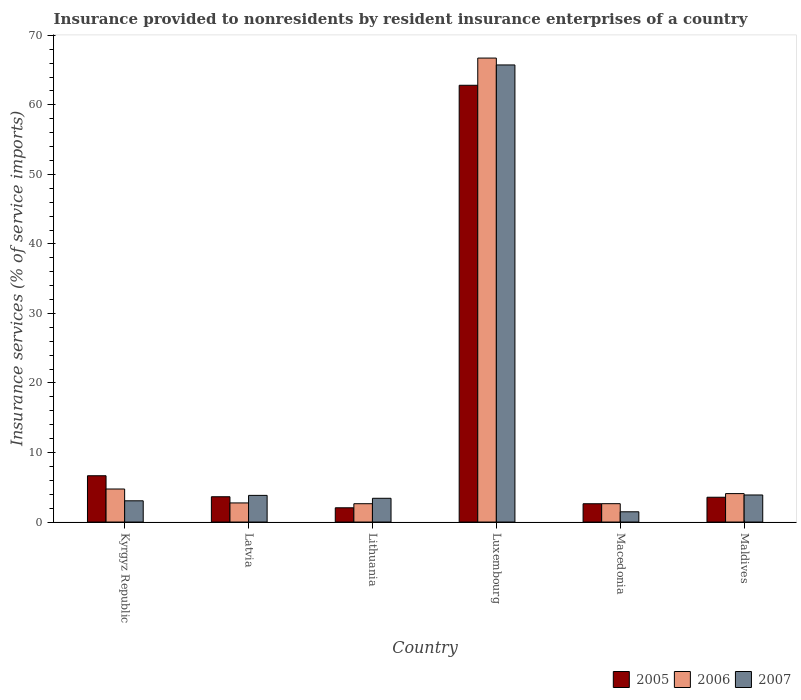How many different coloured bars are there?
Offer a very short reply. 3. Are the number of bars per tick equal to the number of legend labels?
Ensure brevity in your answer.  Yes. How many bars are there on the 3rd tick from the left?
Your answer should be compact. 3. How many bars are there on the 3rd tick from the right?
Provide a short and direct response. 3. What is the label of the 6th group of bars from the left?
Make the answer very short. Maldives. In how many cases, is the number of bars for a given country not equal to the number of legend labels?
Provide a succinct answer. 0. What is the insurance provided to nonresidents in 2007 in Maldives?
Offer a very short reply. 3.89. Across all countries, what is the maximum insurance provided to nonresidents in 2005?
Provide a succinct answer. 62.82. Across all countries, what is the minimum insurance provided to nonresidents in 2006?
Keep it short and to the point. 2.64. In which country was the insurance provided to nonresidents in 2006 maximum?
Provide a short and direct response. Luxembourg. In which country was the insurance provided to nonresidents in 2007 minimum?
Make the answer very short. Macedonia. What is the total insurance provided to nonresidents in 2007 in the graph?
Your response must be concise. 81.41. What is the difference between the insurance provided to nonresidents in 2006 in Latvia and that in Maldives?
Provide a short and direct response. -1.34. What is the difference between the insurance provided to nonresidents in 2005 in Lithuania and the insurance provided to nonresidents in 2007 in Kyrgyz Republic?
Make the answer very short. -1. What is the average insurance provided to nonresidents in 2007 per country?
Ensure brevity in your answer.  13.57. What is the difference between the insurance provided to nonresidents of/in 2005 and insurance provided to nonresidents of/in 2007 in Lithuania?
Make the answer very short. -1.37. In how many countries, is the insurance provided to nonresidents in 2005 greater than 64 %?
Provide a succinct answer. 0. What is the ratio of the insurance provided to nonresidents in 2007 in Lithuania to that in Macedonia?
Make the answer very short. 2.32. Is the insurance provided to nonresidents in 2007 in Kyrgyz Republic less than that in Macedonia?
Provide a short and direct response. No. What is the difference between the highest and the second highest insurance provided to nonresidents in 2005?
Your response must be concise. -59.18. What is the difference between the highest and the lowest insurance provided to nonresidents in 2005?
Offer a very short reply. 60.77. In how many countries, is the insurance provided to nonresidents in 2005 greater than the average insurance provided to nonresidents in 2005 taken over all countries?
Make the answer very short. 1. Is the sum of the insurance provided to nonresidents in 2006 in Latvia and Maldives greater than the maximum insurance provided to nonresidents in 2007 across all countries?
Ensure brevity in your answer.  No. What does the 1st bar from the left in Luxembourg represents?
Your answer should be very brief. 2005. How many bars are there?
Give a very brief answer. 18. Does the graph contain any zero values?
Offer a very short reply. No. How many legend labels are there?
Your response must be concise. 3. How are the legend labels stacked?
Provide a short and direct response. Horizontal. What is the title of the graph?
Give a very brief answer. Insurance provided to nonresidents by resident insurance enterprises of a country. What is the label or title of the X-axis?
Keep it short and to the point. Country. What is the label or title of the Y-axis?
Give a very brief answer. Insurance services (% of service imports). What is the Insurance services (% of service imports) of 2005 in Kyrgyz Republic?
Provide a succinct answer. 6.66. What is the Insurance services (% of service imports) in 2006 in Kyrgyz Republic?
Give a very brief answer. 4.75. What is the Insurance services (% of service imports) in 2007 in Kyrgyz Republic?
Ensure brevity in your answer.  3.05. What is the Insurance services (% of service imports) in 2005 in Latvia?
Make the answer very short. 3.64. What is the Insurance services (% of service imports) in 2006 in Latvia?
Your response must be concise. 2.75. What is the Insurance services (% of service imports) of 2007 in Latvia?
Provide a short and direct response. 3.83. What is the Insurance services (% of service imports) of 2005 in Lithuania?
Your answer should be very brief. 2.05. What is the Insurance services (% of service imports) in 2006 in Lithuania?
Provide a succinct answer. 2.64. What is the Insurance services (% of service imports) in 2007 in Lithuania?
Your answer should be compact. 3.42. What is the Insurance services (% of service imports) of 2005 in Luxembourg?
Give a very brief answer. 62.82. What is the Insurance services (% of service imports) in 2006 in Luxembourg?
Your answer should be very brief. 66.73. What is the Insurance services (% of service imports) of 2007 in Luxembourg?
Provide a succinct answer. 65.74. What is the Insurance services (% of service imports) of 2005 in Macedonia?
Give a very brief answer. 2.63. What is the Insurance services (% of service imports) in 2006 in Macedonia?
Provide a short and direct response. 2.64. What is the Insurance services (% of service imports) in 2007 in Macedonia?
Make the answer very short. 1.47. What is the Insurance services (% of service imports) in 2005 in Maldives?
Give a very brief answer. 3.57. What is the Insurance services (% of service imports) in 2006 in Maldives?
Give a very brief answer. 4.09. What is the Insurance services (% of service imports) of 2007 in Maldives?
Provide a succinct answer. 3.89. Across all countries, what is the maximum Insurance services (% of service imports) of 2005?
Your response must be concise. 62.82. Across all countries, what is the maximum Insurance services (% of service imports) of 2006?
Make the answer very short. 66.73. Across all countries, what is the maximum Insurance services (% of service imports) of 2007?
Make the answer very short. 65.74. Across all countries, what is the minimum Insurance services (% of service imports) in 2005?
Offer a terse response. 2.05. Across all countries, what is the minimum Insurance services (% of service imports) of 2006?
Offer a terse response. 2.64. Across all countries, what is the minimum Insurance services (% of service imports) in 2007?
Your response must be concise. 1.47. What is the total Insurance services (% of service imports) in 2005 in the graph?
Offer a terse response. 81.36. What is the total Insurance services (% of service imports) in 2006 in the graph?
Ensure brevity in your answer.  83.59. What is the total Insurance services (% of service imports) of 2007 in the graph?
Give a very brief answer. 81.41. What is the difference between the Insurance services (% of service imports) in 2005 in Kyrgyz Republic and that in Latvia?
Keep it short and to the point. 3.02. What is the difference between the Insurance services (% of service imports) of 2006 in Kyrgyz Republic and that in Latvia?
Your answer should be very brief. 2. What is the difference between the Insurance services (% of service imports) in 2007 in Kyrgyz Republic and that in Latvia?
Ensure brevity in your answer.  -0.78. What is the difference between the Insurance services (% of service imports) of 2005 in Kyrgyz Republic and that in Lithuania?
Give a very brief answer. 4.61. What is the difference between the Insurance services (% of service imports) in 2006 in Kyrgyz Republic and that in Lithuania?
Provide a succinct answer. 2.11. What is the difference between the Insurance services (% of service imports) in 2007 in Kyrgyz Republic and that in Lithuania?
Offer a terse response. -0.36. What is the difference between the Insurance services (% of service imports) in 2005 in Kyrgyz Republic and that in Luxembourg?
Your response must be concise. -56.16. What is the difference between the Insurance services (% of service imports) in 2006 in Kyrgyz Republic and that in Luxembourg?
Offer a terse response. -61.98. What is the difference between the Insurance services (% of service imports) in 2007 in Kyrgyz Republic and that in Luxembourg?
Your answer should be compact. -62.69. What is the difference between the Insurance services (% of service imports) in 2005 in Kyrgyz Republic and that in Macedonia?
Provide a succinct answer. 4.03. What is the difference between the Insurance services (% of service imports) in 2006 in Kyrgyz Republic and that in Macedonia?
Offer a very short reply. 2.11. What is the difference between the Insurance services (% of service imports) in 2007 in Kyrgyz Republic and that in Macedonia?
Offer a terse response. 1.58. What is the difference between the Insurance services (% of service imports) of 2005 in Kyrgyz Republic and that in Maldives?
Offer a terse response. 3.09. What is the difference between the Insurance services (% of service imports) in 2006 in Kyrgyz Republic and that in Maldives?
Offer a terse response. 0.66. What is the difference between the Insurance services (% of service imports) in 2007 in Kyrgyz Republic and that in Maldives?
Provide a succinct answer. -0.84. What is the difference between the Insurance services (% of service imports) of 2005 in Latvia and that in Lithuania?
Your answer should be very brief. 1.59. What is the difference between the Insurance services (% of service imports) of 2006 in Latvia and that in Lithuania?
Ensure brevity in your answer.  0.11. What is the difference between the Insurance services (% of service imports) of 2007 in Latvia and that in Lithuania?
Provide a succinct answer. 0.42. What is the difference between the Insurance services (% of service imports) in 2005 in Latvia and that in Luxembourg?
Ensure brevity in your answer.  -59.18. What is the difference between the Insurance services (% of service imports) in 2006 in Latvia and that in Luxembourg?
Provide a short and direct response. -63.98. What is the difference between the Insurance services (% of service imports) of 2007 in Latvia and that in Luxembourg?
Offer a terse response. -61.91. What is the difference between the Insurance services (% of service imports) in 2005 in Latvia and that in Macedonia?
Keep it short and to the point. 1.01. What is the difference between the Insurance services (% of service imports) in 2006 in Latvia and that in Macedonia?
Provide a short and direct response. 0.11. What is the difference between the Insurance services (% of service imports) of 2007 in Latvia and that in Macedonia?
Offer a very short reply. 2.36. What is the difference between the Insurance services (% of service imports) in 2005 in Latvia and that in Maldives?
Keep it short and to the point. 0.07. What is the difference between the Insurance services (% of service imports) in 2006 in Latvia and that in Maldives?
Provide a short and direct response. -1.34. What is the difference between the Insurance services (% of service imports) of 2007 in Latvia and that in Maldives?
Offer a terse response. -0.06. What is the difference between the Insurance services (% of service imports) in 2005 in Lithuania and that in Luxembourg?
Offer a terse response. -60.77. What is the difference between the Insurance services (% of service imports) of 2006 in Lithuania and that in Luxembourg?
Ensure brevity in your answer.  -64.09. What is the difference between the Insurance services (% of service imports) in 2007 in Lithuania and that in Luxembourg?
Provide a succinct answer. -62.33. What is the difference between the Insurance services (% of service imports) of 2005 in Lithuania and that in Macedonia?
Your answer should be compact. -0.58. What is the difference between the Insurance services (% of service imports) of 2006 in Lithuania and that in Macedonia?
Give a very brief answer. -0. What is the difference between the Insurance services (% of service imports) of 2007 in Lithuania and that in Macedonia?
Your answer should be compact. 1.94. What is the difference between the Insurance services (% of service imports) of 2005 in Lithuania and that in Maldives?
Your answer should be very brief. -1.52. What is the difference between the Insurance services (% of service imports) of 2006 in Lithuania and that in Maldives?
Keep it short and to the point. -1.45. What is the difference between the Insurance services (% of service imports) in 2007 in Lithuania and that in Maldives?
Your response must be concise. -0.48. What is the difference between the Insurance services (% of service imports) of 2005 in Luxembourg and that in Macedonia?
Give a very brief answer. 60.19. What is the difference between the Insurance services (% of service imports) in 2006 in Luxembourg and that in Macedonia?
Your answer should be very brief. 64.09. What is the difference between the Insurance services (% of service imports) in 2007 in Luxembourg and that in Macedonia?
Offer a very short reply. 64.27. What is the difference between the Insurance services (% of service imports) of 2005 in Luxembourg and that in Maldives?
Offer a terse response. 59.25. What is the difference between the Insurance services (% of service imports) of 2006 in Luxembourg and that in Maldives?
Provide a short and direct response. 62.64. What is the difference between the Insurance services (% of service imports) in 2007 in Luxembourg and that in Maldives?
Your answer should be compact. 61.85. What is the difference between the Insurance services (% of service imports) in 2005 in Macedonia and that in Maldives?
Ensure brevity in your answer.  -0.93. What is the difference between the Insurance services (% of service imports) of 2006 in Macedonia and that in Maldives?
Give a very brief answer. -1.45. What is the difference between the Insurance services (% of service imports) of 2007 in Macedonia and that in Maldives?
Offer a terse response. -2.42. What is the difference between the Insurance services (% of service imports) of 2005 in Kyrgyz Republic and the Insurance services (% of service imports) of 2006 in Latvia?
Your response must be concise. 3.91. What is the difference between the Insurance services (% of service imports) in 2005 in Kyrgyz Republic and the Insurance services (% of service imports) in 2007 in Latvia?
Ensure brevity in your answer.  2.83. What is the difference between the Insurance services (% of service imports) in 2006 in Kyrgyz Republic and the Insurance services (% of service imports) in 2007 in Latvia?
Provide a short and direct response. 0.92. What is the difference between the Insurance services (% of service imports) in 2005 in Kyrgyz Republic and the Insurance services (% of service imports) in 2006 in Lithuania?
Your answer should be very brief. 4.02. What is the difference between the Insurance services (% of service imports) of 2005 in Kyrgyz Republic and the Insurance services (% of service imports) of 2007 in Lithuania?
Your answer should be very brief. 3.24. What is the difference between the Insurance services (% of service imports) in 2006 in Kyrgyz Republic and the Insurance services (% of service imports) in 2007 in Lithuania?
Provide a succinct answer. 1.34. What is the difference between the Insurance services (% of service imports) of 2005 in Kyrgyz Republic and the Insurance services (% of service imports) of 2006 in Luxembourg?
Your response must be concise. -60.07. What is the difference between the Insurance services (% of service imports) of 2005 in Kyrgyz Republic and the Insurance services (% of service imports) of 2007 in Luxembourg?
Give a very brief answer. -59.08. What is the difference between the Insurance services (% of service imports) of 2006 in Kyrgyz Republic and the Insurance services (% of service imports) of 2007 in Luxembourg?
Provide a short and direct response. -60.99. What is the difference between the Insurance services (% of service imports) in 2005 in Kyrgyz Republic and the Insurance services (% of service imports) in 2006 in Macedonia?
Provide a short and direct response. 4.02. What is the difference between the Insurance services (% of service imports) in 2005 in Kyrgyz Republic and the Insurance services (% of service imports) in 2007 in Macedonia?
Make the answer very short. 5.19. What is the difference between the Insurance services (% of service imports) of 2006 in Kyrgyz Republic and the Insurance services (% of service imports) of 2007 in Macedonia?
Offer a very short reply. 3.28. What is the difference between the Insurance services (% of service imports) of 2005 in Kyrgyz Republic and the Insurance services (% of service imports) of 2006 in Maldives?
Give a very brief answer. 2.57. What is the difference between the Insurance services (% of service imports) in 2005 in Kyrgyz Republic and the Insurance services (% of service imports) in 2007 in Maldives?
Ensure brevity in your answer.  2.77. What is the difference between the Insurance services (% of service imports) in 2006 in Kyrgyz Republic and the Insurance services (% of service imports) in 2007 in Maldives?
Offer a very short reply. 0.86. What is the difference between the Insurance services (% of service imports) of 2005 in Latvia and the Insurance services (% of service imports) of 2006 in Lithuania?
Provide a succinct answer. 1. What is the difference between the Insurance services (% of service imports) in 2005 in Latvia and the Insurance services (% of service imports) in 2007 in Lithuania?
Make the answer very short. 0.22. What is the difference between the Insurance services (% of service imports) in 2005 in Latvia and the Insurance services (% of service imports) in 2006 in Luxembourg?
Offer a terse response. -63.09. What is the difference between the Insurance services (% of service imports) of 2005 in Latvia and the Insurance services (% of service imports) of 2007 in Luxembourg?
Offer a very short reply. -62.1. What is the difference between the Insurance services (% of service imports) of 2006 in Latvia and the Insurance services (% of service imports) of 2007 in Luxembourg?
Your answer should be very brief. -62.99. What is the difference between the Insurance services (% of service imports) in 2005 in Latvia and the Insurance services (% of service imports) in 2007 in Macedonia?
Offer a terse response. 2.16. What is the difference between the Insurance services (% of service imports) in 2006 in Latvia and the Insurance services (% of service imports) in 2007 in Macedonia?
Provide a succinct answer. 1.28. What is the difference between the Insurance services (% of service imports) of 2005 in Latvia and the Insurance services (% of service imports) of 2006 in Maldives?
Make the answer very short. -0.45. What is the difference between the Insurance services (% of service imports) in 2005 in Latvia and the Insurance services (% of service imports) in 2007 in Maldives?
Give a very brief answer. -0.25. What is the difference between the Insurance services (% of service imports) of 2006 in Latvia and the Insurance services (% of service imports) of 2007 in Maldives?
Your answer should be very brief. -1.14. What is the difference between the Insurance services (% of service imports) in 2005 in Lithuania and the Insurance services (% of service imports) in 2006 in Luxembourg?
Your answer should be very brief. -64.68. What is the difference between the Insurance services (% of service imports) in 2005 in Lithuania and the Insurance services (% of service imports) in 2007 in Luxembourg?
Your response must be concise. -63.69. What is the difference between the Insurance services (% of service imports) of 2006 in Lithuania and the Insurance services (% of service imports) of 2007 in Luxembourg?
Make the answer very short. -63.1. What is the difference between the Insurance services (% of service imports) of 2005 in Lithuania and the Insurance services (% of service imports) of 2006 in Macedonia?
Your answer should be very brief. -0.59. What is the difference between the Insurance services (% of service imports) in 2005 in Lithuania and the Insurance services (% of service imports) in 2007 in Macedonia?
Offer a very short reply. 0.58. What is the difference between the Insurance services (% of service imports) in 2006 in Lithuania and the Insurance services (% of service imports) in 2007 in Macedonia?
Keep it short and to the point. 1.16. What is the difference between the Insurance services (% of service imports) of 2005 in Lithuania and the Insurance services (% of service imports) of 2006 in Maldives?
Provide a short and direct response. -2.04. What is the difference between the Insurance services (% of service imports) of 2005 in Lithuania and the Insurance services (% of service imports) of 2007 in Maldives?
Your response must be concise. -1.84. What is the difference between the Insurance services (% of service imports) of 2006 in Lithuania and the Insurance services (% of service imports) of 2007 in Maldives?
Your answer should be compact. -1.25. What is the difference between the Insurance services (% of service imports) in 2005 in Luxembourg and the Insurance services (% of service imports) in 2006 in Macedonia?
Keep it short and to the point. 60.18. What is the difference between the Insurance services (% of service imports) of 2005 in Luxembourg and the Insurance services (% of service imports) of 2007 in Macedonia?
Your response must be concise. 61.35. What is the difference between the Insurance services (% of service imports) in 2006 in Luxembourg and the Insurance services (% of service imports) in 2007 in Macedonia?
Your answer should be compact. 65.26. What is the difference between the Insurance services (% of service imports) in 2005 in Luxembourg and the Insurance services (% of service imports) in 2006 in Maldives?
Your answer should be very brief. 58.73. What is the difference between the Insurance services (% of service imports) of 2005 in Luxembourg and the Insurance services (% of service imports) of 2007 in Maldives?
Your answer should be compact. 58.93. What is the difference between the Insurance services (% of service imports) of 2006 in Luxembourg and the Insurance services (% of service imports) of 2007 in Maldives?
Ensure brevity in your answer.  62.84. What is the difference between the Insurance services (% of service imports) in 2005 in Macedonia and the Insurance services (% of service imports) in 2006 in Maldives?
Your answer should be compact. -1.46. What is the difference between the Insurance services (% of service imports) in 2005 in Macedonia and the Insurance services (% of service imports) in 2007 in Maldives?
Your response must be concise. -1.26. What is the difference between the Insurance services (% of service imports) of 2006 in Macedonia and the Insurance services (% of service imports) of 2007 in Maldives?
Your response must be concise. -1.25. What is the average Insurance services (% of service imports) of 2005 per country?
Your response must be concise. 13.56. What is the average Insurance services (% of service imports) in 2006 per country?
Provide a succinct answer. 13.93. What is the average Insurance services (% of service imports) in 2007 per country?
Your response must be concise. 13.57. What is the difference between the Insurance services (% of service imports) of 2005 and Insurance services (% of service imports) of 2006 in Kyrgyz Republic?
Your answer should be very brief. 1.91. What is the difference between the Insurance services (% of service imports) of 2005 and Insurance services (% of service imports) of 2007 in Kyrgyz Republic?
Your answer should be compact. 3.61. What is the difference between the Insurance services (% of service imports) of 2006 and Insurance services (% of service imports) of 2007 in Kyrgyz Republic?
Make the answer very short. 1.7. What is the difference between the Insurance services (% of service imports) in 2005 and Insurance services (% of service imports) in 2006 in Latvia?
Ensure brevity in your answer.  0.89. What is the difference between the Insurance services (% of service imports) in 2005 and Insurance services (% of service imports) in 2007 in Latvia?
Offer a terse response. -0.2. What is the difference between the Insurance services (% of service imports) of 2006 and Insurance services (% of service imports) of 2007 in Latvia?
Your response must be concise. -1.08. What is the difference between the Insurance services (% of service imports) of 2005 and Insurance services (% of service imports) of 2006 in Lithuania?
Your answer should be very brief. -0.59. What is the difference between the Insurance services (% of service imports) in 2005 and Insurance services (% of service imports) in 2007 in Lithuania?
Keep it short and to the point. -1.37. What is the difference between the Insurance services (% of service imports) of 2006 and Insurance services (% of service imports) of 2007 in Lithuania?
Offer a terse response. -0.78. What is the difference between the Insurance services (% of service imports) of 2005 and Insurance services (% of service imports) of 2006 in Luxembourg?
Offer a terse response. -3.91. What is the difference between the Insurance services (% of service imports) of 2005 and Insurance services (% of service imports) of 2007 in Luxembourg?
Provide a succinct answer. -2.92. What is the difference between the Insurance services (% of service imports) of 2005 and Insurance services (% of service imports) of 2006 in Macedonia?
Offer a terse response. -0.01. What is the difference between the Insurance services (% of service imports) in 2005 and Insurance services (% of service imports) in 2007 in Macedonia?
Ensure brevity in your answer.  1.16. What is the difference between the Insurance services (% of service imports) in 2006 and Insurance services (% of service imports) in 2007 in Macedonia?
Your answer should be compact. 1.17. What is the difference between the Insurance services (% of service imports) of 2005 and Insurance services (% of service imports) of 2006 in Maldives?
Provide a succinct answer. -0.52. What is the difference between the Insurance services (% of service imports) in 2005 and Insurance services (% of service imports) in 2007 in Maldives?
Your answer should be very brief. -0.33. What is the difference between the Insurance services (% of service imports) of 2006 and Insurance services (% of service imports) of 2007 in Maldives?
Your answer should be compact. 0.2. What is the ratio of the Insurance services (% of service imports) in 2005 in Kyrgyz Republic to that in Latvia?
Provide a succinct answer. 1.83. What is the ratio of the Insurance services (% of service imports) of 2006 in Kyrgyz Republic to that in Latvia?
Ensure brevity in your answer.  1.73. What is the ratio of the Insurance services (% of service imports) in 2007 in Kyrgyz Republic to that in Latvia?
Your answer should be compact. 0.8. What is the ratio of the Insurance services (% of service imports) of 2005 in Kyrgyz Republic to that in Lithuania?
Provide a short and direct response. 3.25. What is the ratio of the Insurance services (% of service imports) in 2006 in Kyrgyz Republic to that in Lithuania?
Your answer should be compact. 1.8. What is the ratio of the Insurance services (% of service imports) of 2007 in Kyrgyz Republic to that in Lithuania?
Offer a terse response. 0.89. What is the ratio of the Insurance services (% of service imports) of 2005 in Kyrgyz Republic to that in Luxembourg?
Make the answer very short. 0.11. What is the ratio of the Insurance services (% of service imports) of 2006 in Kyrgyz Republic to that in Luxembourg?
Your response must be concise. 0.07. What is the ratio of the Insurance services (% of service imports) in 2007 in Kyrgyz Republic to that in Luxembourg?
Keep it short and to the point. 0.05. What is the ratio of the Insurance services (% of service imports) in 2005 in Kyrgyz Republic to that in Macedonia?
Keep it short and to the point. 2.53. What is the ratio of the Insurance services (% of service imports) in 2006 in Kyrgyz Republic to that in Macedonia?
Keep it short and to the point. 1.8. What is the ratio of the Insurance services (% of service imports) of 2007 in Kyrgyz Republic to that in Macedonia?
Keep it short and to the point. 2.07. What is the ratio of the Insurance services (% of service imports) of 2005 in Kyrgyz Republic to that in Maldives?
Make the answer very short. 1.87. What is the ratio of the Insurance services (% of service imports) in 2006 in Kyrgyz Republic to that in Maldives?
Offer a very short reply. 1.16. What is the ratio of the Insurance services (% of service imports) of 2007 in Kyrgyz Republic to that in Maldives?
Keep it short and to the point. 0.78. What is the ratio of the Insurance services (% of service imports) of 2005 in Latvia to that in Lithuania?
Your answer should be compact. 1.77. What is the ratio of the Insurance services (% of service imports) of 2006 in Latvia to that in Lithuania?
Provide a short and direct response. 1.04. What is the ratio of the Insurance services (% of service imports) in 2007 in Latvia to that in Lithuania?
Offer a very short reply. 1.12. What is the ratio of the Insurance services (% of service imports) in 2005 in Latvia to that in Luxembourg?
Ensure brevity in your answer.  0.06. What is the ratio of the Insurance services (% of service imports) of 2006 in Latvia to that in Luxembourg?
Ensure brevity in your answer.  0.04. What is the ratio of the Insurance services (% of service imports) in 2007 in Latvia to that in Luxembourg?
Provide a succinct answer. 0.06. What is the ratio of the Insurance services (% of service imports) of 2005 in Latvia to that in Macedonia?
Provide a short and direct response. 1.38. What is the ratio of the Insurance services (% of service imports) in 2006 in Latvia to that in Macedonia?
Your answer should be very brief. 1.04. What is the ratio of the Insurance services (% of service imports) of 2007 in Latvia to that in Macedonia?
Provide a short and direct response. 2.6. What is the ratio of the Insurance services (% of service imports) in 2005 in Latvia to that in Maldives?
Your response must be concise. 1.02. What is the ratio of the Insurance services (% of service imports) of 2006 in Latvia to that in Maldives?
Provide a succinct answer. 0.67. What is the ratio of the Insurance services (% of service imports) of 2007 in Latvia to that in Maldives?
Ensure brevity in your answer.  0.99. What is the ratio of the Insurance services (% of service imports) of 2005 in Lithuania to that in Luxembourg?
Make the answer very short. 0.03. What is the ratio of the Insurance services (% of service imports) of 2006 in Lithuania to that in Luxembourg?
Make the answer very short. 0.04. What is the ratio of the Insurance services (% of service imports) of 2007 in Lithuania to that in Luxembourg?
Provide a succinct answer. 0.05. What is the ratio of the Insurance services (% of service imports) in 2005 in Lithuania to that in Macedonia?
Provide a short and direct response. 0.78. What is the ratio of the Insurance services (% of service imports) of 2006 in Lithuania to that in Macedonia?
Keep it short and to the point. 1. What is the ratio of the Insurance services (% of service imports) in 2007 in Lithuania to that in Macedonia?
Offer a terse response. 2.32. What is the ratio of the Insurance services (% of service imports) in 2005 in Lithuania to that in Maldives?
Keep it short and to the point. 0.57. What is the ratio of the Insurance services (% of service imports) of 2006 in Lithuania to that in Maldives?
Your answer should be compact. 0.64. What is the ratio of the Insurance services (% of service imports) of 2007 in Lithuania to that in Maldives?
Keep it short and to the point. 0.88. What is the ratio of the Insurance services (% of service imports) in 2005 in Luxembourg to that in Macedonia?
Your response must be concise. 23.87. What is the ratio of the Insurance services (% of service imports) of 2006 in Luxembourg to that in Macedonia?
Offer a very short reply. 25.28. What is the ratio of the Insurance services (% of service imports) in 2007 in Luxembourg to that in Macedonia?
Ensure brevity in your answer.  44.64. What is the ratio of the Insurance services (% of service imports) of 2005 in Luxembourg to that in Maldives?
Provide a succinct answer. 17.62. What is the ratio of the Insurance services (% of service imports) in 2006 in Luxembourg to that in Maldives?
Give a very brief answer. 16.32. What is the ratio of the Insurance services (% of service imports) of 2007 in Luxembourg to that in Maldives?
Provide a short and direct response. 16.9. What is the ratio of the Insurance services (% of service imports) of 2005 in Macedonia to that in Maldives?
Offer a very short reply. 0.74. What is the ratio of the Insurance services (% of service imports) of 2006 in Macedonia to that in Maldives?
Provide a short and direct response. 0.65. What is the ratio of the Insurance services (% of service imports) in 2007 in Macedonia to that in Maldives?
Keep it short and to the point. 0.38. What is the difference between the highest and the second highest Insurance services (% of service imports) of 2005?
Ensure brevity in your answer.  56.16. What is the difference between the highest and the second highest Insurance services (% of service imports) in 2006?
Your answer should be very brief. 61.98. What is the difference between the highest and the second highest Insurance services (% of service imports) of 2007?
Your answer should be compact. 61.85. What is the difference between the highest and the lowest Insurance services (% of service imports) in 2005?
Offer a terse response. 60.77. What is the difference between the highest and the lowest Insurance services (% of service imports) in 2006?
Give a very brief answer. 64.09. What is the difference between the highest and the lowest Insurance services (% of service imports) in 2007?
Your answer should be compact. 64.27. 